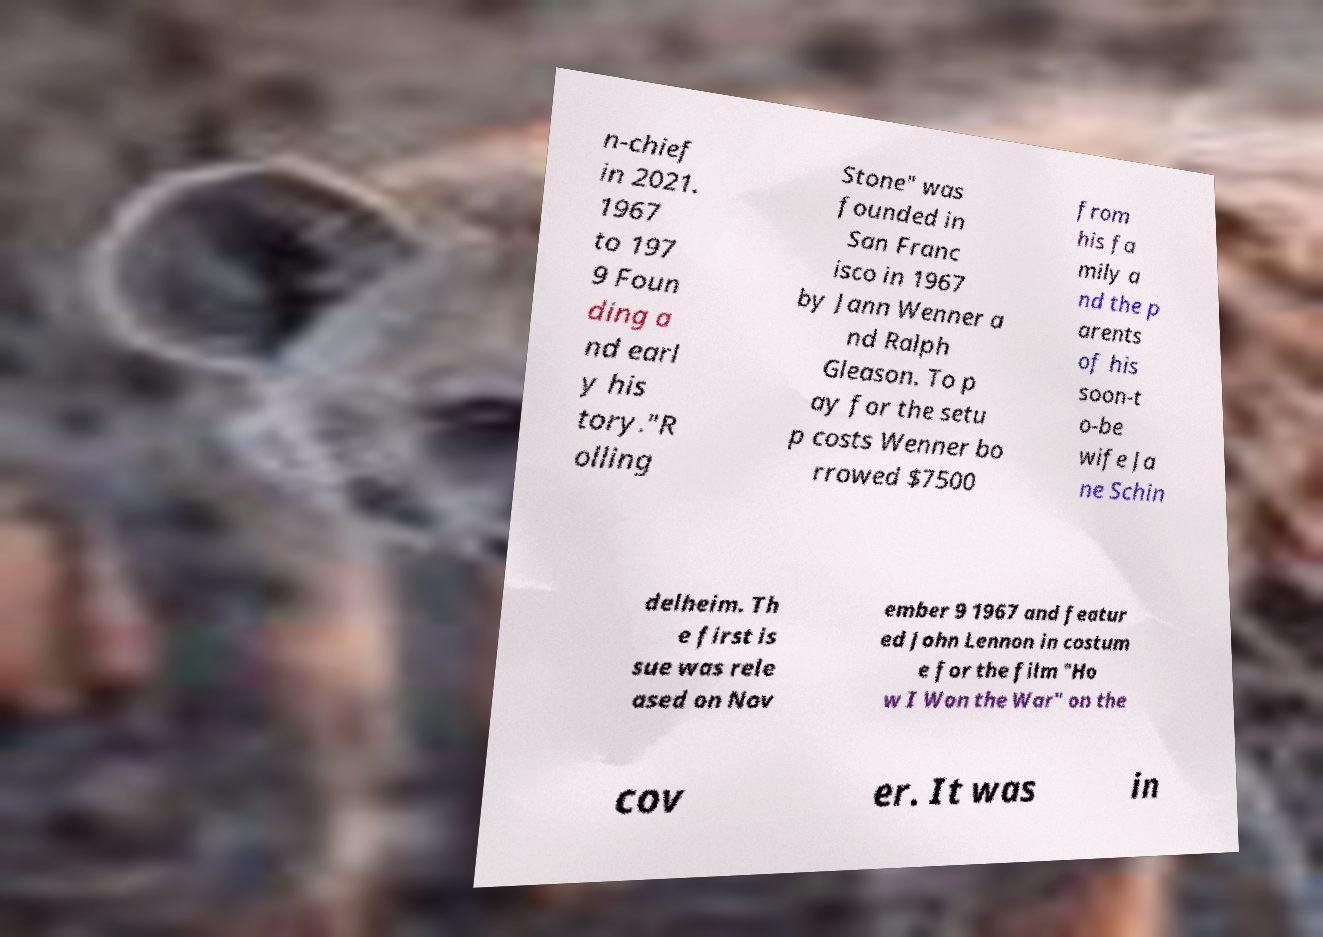What messages or text are displayed in this image? I need them in a readable, typed format. n-chief in 2021. 1967 to 197 9 Foun ding a nd earl y his tory."R olling Stone" was founded in San Franc isco in 1967 by Jann Wenner a nd Ralph Gleason. To p ay for the setu p costs Wenner bo rrowed $7500 from his fa mily a nd the p arents of his soon-t o-be wife Ja ne Schin delheim. Th e first is sue was rele ased on Nov ember 9 1967 and featur ed John Lennon in costum e for the film "Ho w I Won the War" on the cov er. It was in 